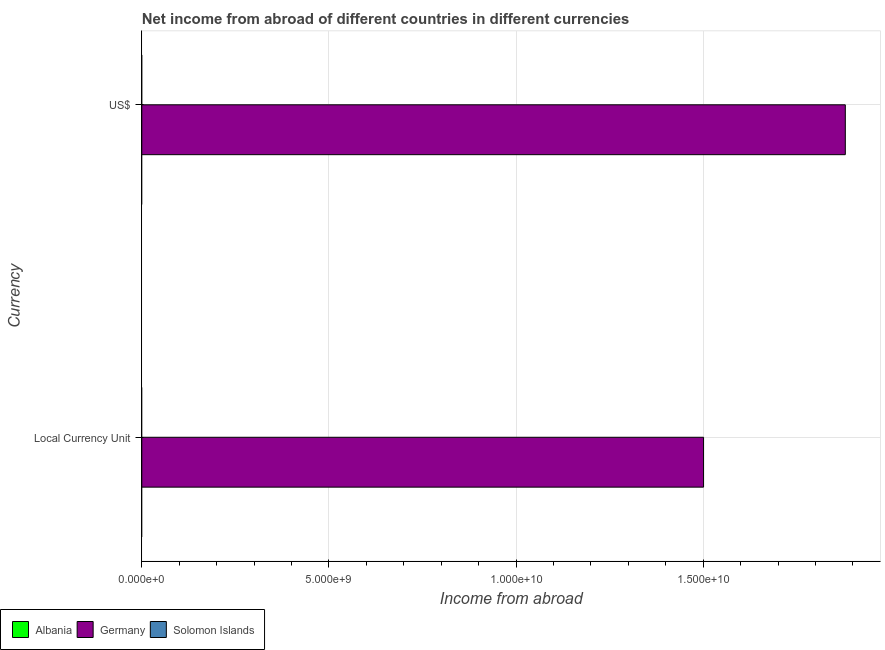How many different coloured bars are there?
Keep it short and to the point. 1. Are the number of bars on each tick of the Y-axis equal?
Your answer should be very brief. Yes. How many bars are there on the 1st tick from the bottom?
Provide a short and direct response. 1. What is the label of the 1st group of bars from the top?
Offer a terse response. US$. What is the income from abroad in constant 2005 us$ in Albania?
Your answer should be compact. 0. Across all countries, what is the maximum income from abroad in us$?
Give a very brief answer. 1.88e+1. Across all countries, what is the minimum income from abroad in constant 2005 us$?
Keep it short and to the point. 0. In which country was the income from abroad in constant 2005 us$ maximum?
Your answer should be compact. Germany. What is the total income from abroad in us$ in the graph?
Your answer should be compact. 1.88e+1. What is the difference between the income from abroad in constant 2005 us$ in Germany and the income from abroad in us$ in Solomon Islands?
Your answer should be compact. 1.50e+1. What is the average income from abroad in us$ per country?
Your answer should be compact. 6.27e+09. What is the difference between the income from abroad in us$ and income from abroad in constant 2005 us$ in Germany?
Offer a terse response. 3.79e+09. How many bars are there?
Offer a terse response. 2. Are all the bars in the graph horizontal?
Offer a very short reply. Yes. How many countries are there in the graph?
Keep it short and to the point. 3. Does the graph contain grids?
Ensure brevity in your answer.  Yes. Where does the legend appear in the graph?
Your response must be concise. Bottom left. How many legend labels are there?
Give a very brief answer. 3. What is the title of the graph?
Your response must be concise. Net income from abroad of different countries in different currencies. What is the label or title of the X-axis?
Give a very brief answer. Income from abroad. What is the label or title of the Y-axis?
Offer a very short reply. Currency. What is the Income from abroad in Germany in Local Currency Unit?
Your response must be concise. 1.50e+1. What is the Income from abroad of Germany in US$?
Offer a terse response. 1.88e+1. What is the Income from abroad in Solomon Islands in US$?
Your answer should be very brief. 0. Across all Currency, what is the maximum Income from abroad in Germany?
Offer a terse response. 1.88e+1. Across all Currency, what is the minimum Income from abroad of Germany?
Your answer should be compact. 1.50e+1. What is the total Income from abroad in Germany in the graph?
Offer a terse response. 3.38e+1. What is the difference between the Income from abroad of Germany in Local Currency Unit and that in US$?
Make the answer very short. -3.79e+09. What is the average Income from abroad in Albania per Currency?
Your response must be concise. 0. What is the average Income from abroad in Germany per Currency?
Make the answer very short. 1.69e+1. What is the ratio of the Income from abroad in Germany in Local Currency Unit to that in US$?
Provide a succinct answer. 0.8. What is the difference between the highest and the second highest Income from abroad of Germany?
Provide a succinct answer. 3.79e+09. What is the difference between the highest and the lowest Income from abroad in Germany?
Keep it short and to the point. 3.79e+09. 